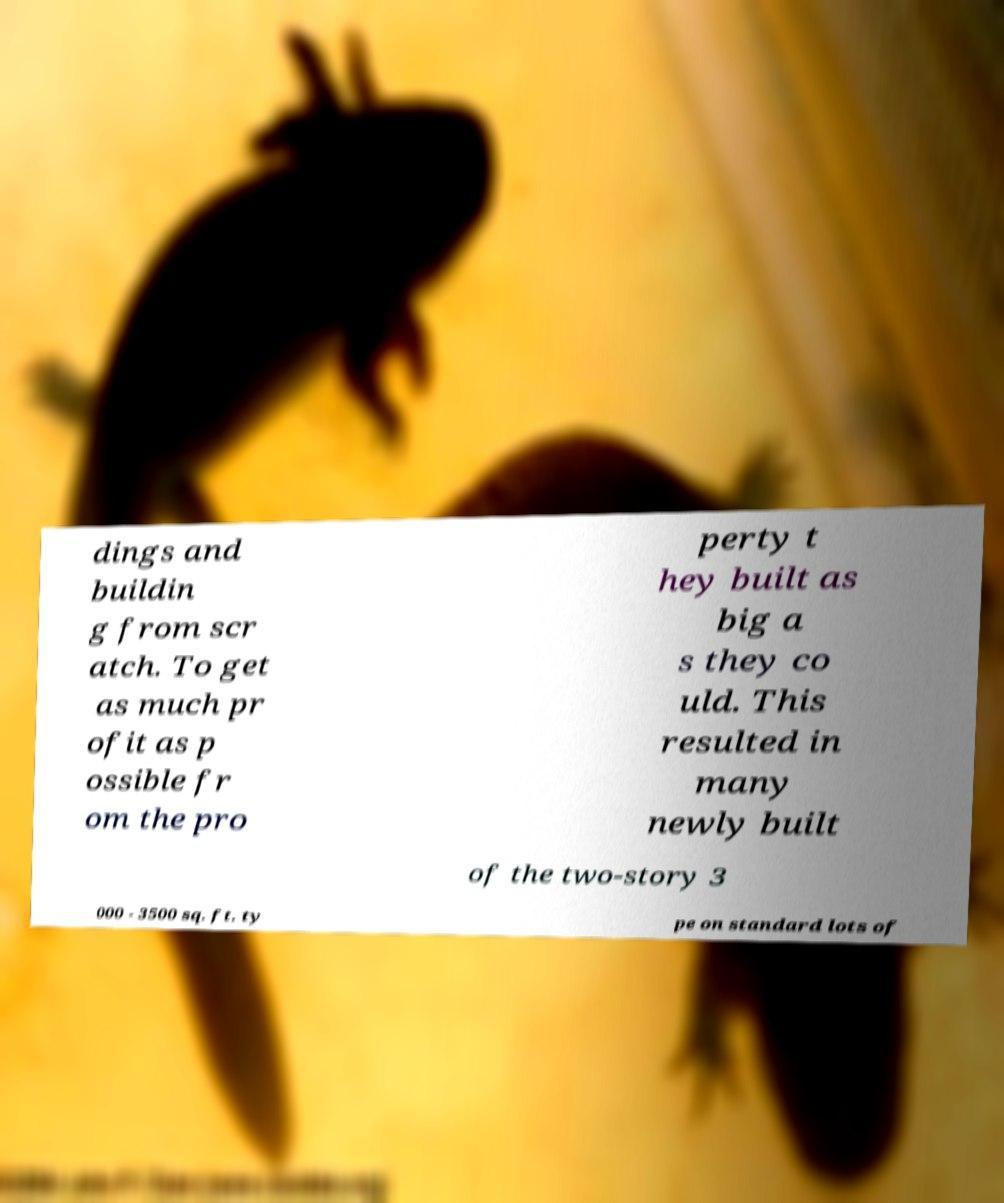Please read and relay the text visible in this image. What does it say? dings and buildin g from scr atch. To get as much pr ofit as p ossible fr om the pro perty t hey built as big a s they co uld. This resulted in many newly built of the two-story 3 000 - 3500 sq. ft. ty pe on standard lots of 